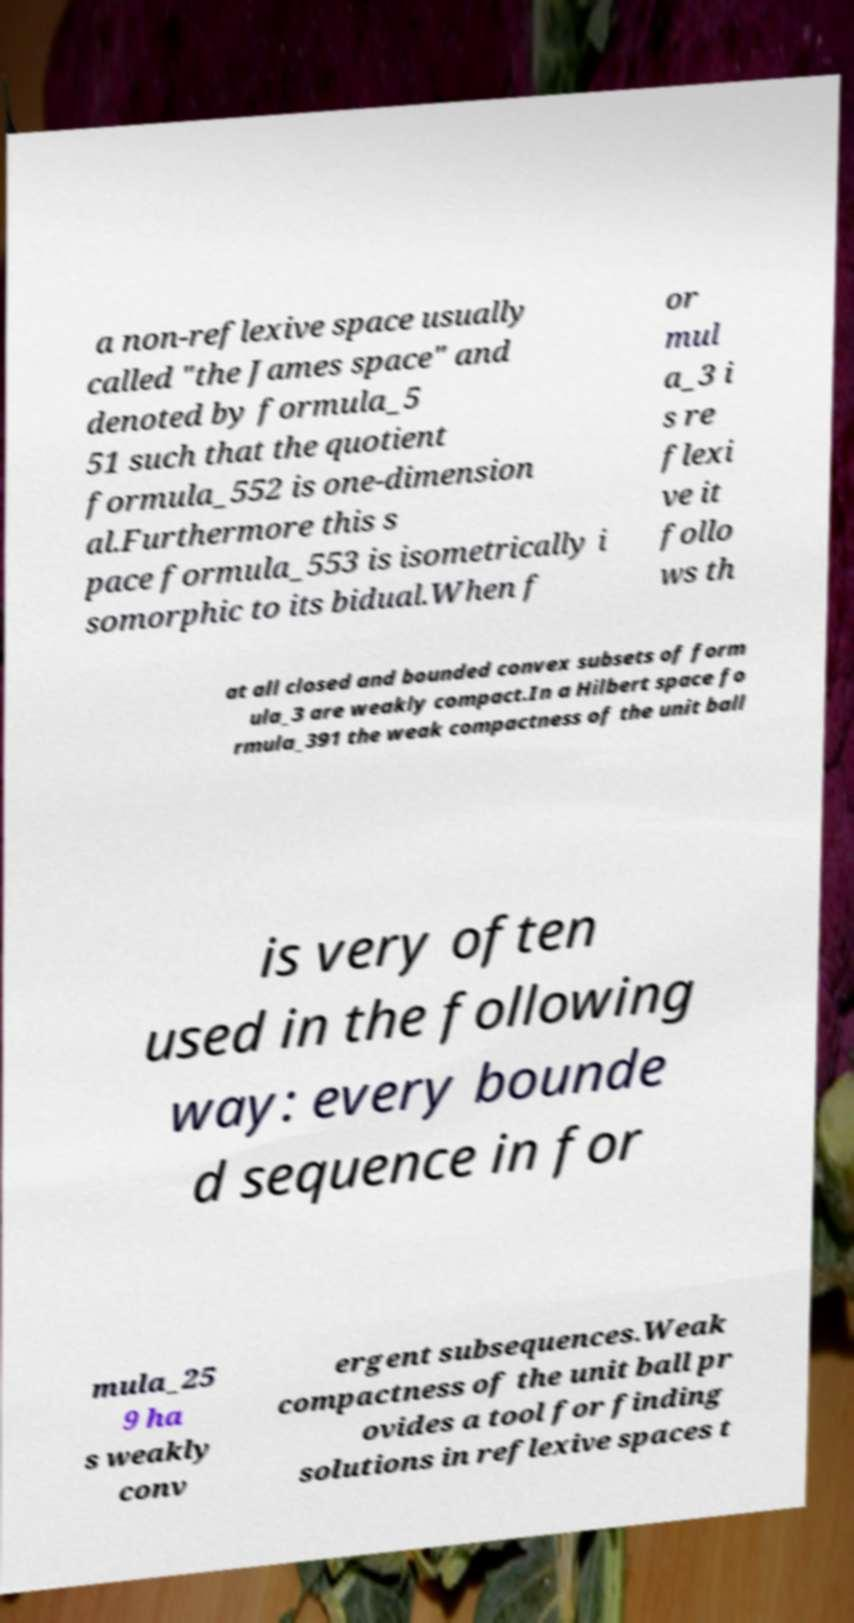Please read and relay the text visible in this image. What does it say? a non-reflexive space usually called "the James space" and denoted by formula_5 51 such that the quotient formula_552 is one-dimension al.Furthermore this s pace formula_553 is isometrically i somorphic to its bidual.When f or mul a_3 i s re flexi ve it follo ws th at all closed and bounded convex subsets of form ula_3 are weakly compact.In a Hilbert space fo rmula_391 the weak compactness of the unit ball is very often used in the following way: every bounde d sequence in for mula_25 9 ha s weakly conv ergent subsequences.Weak compactness of the unit ball pr ovides a tool for finding solutions in reflexive spaces t 